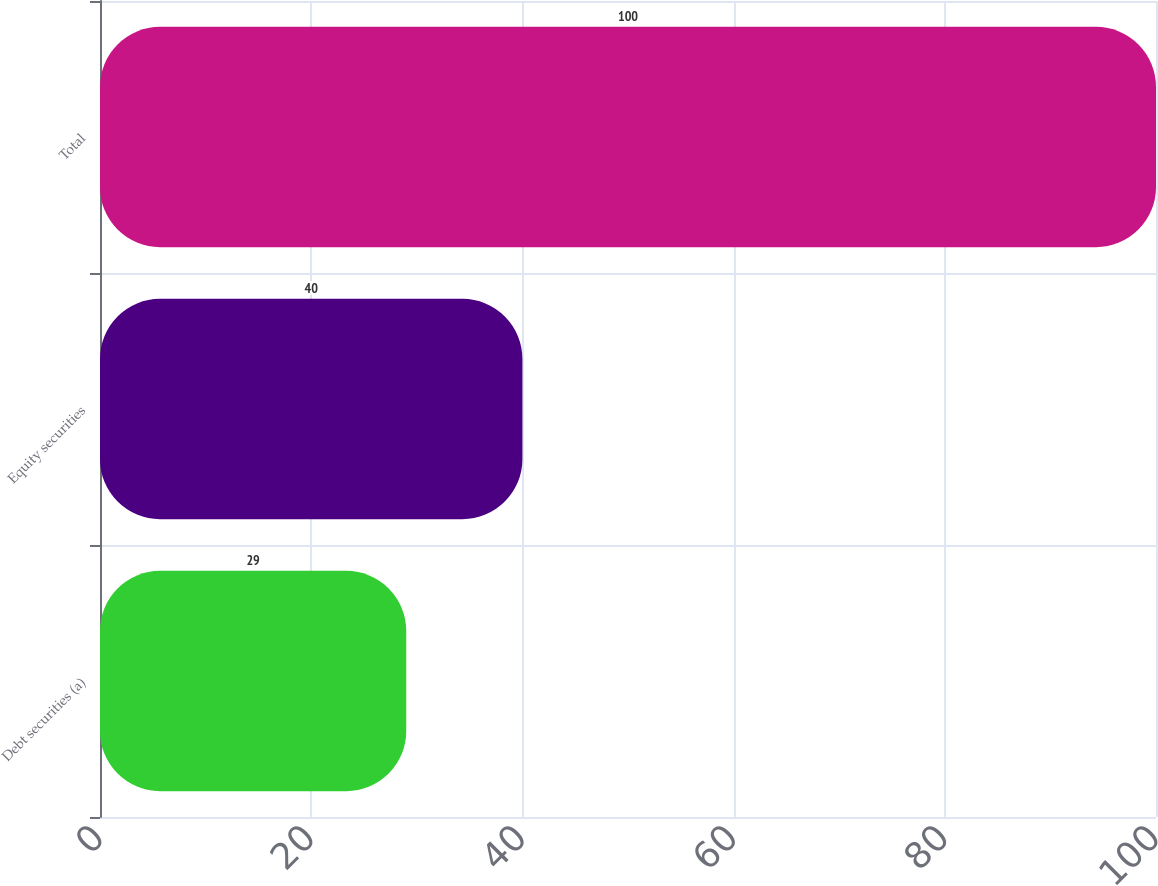<chart> <loc_0><loc_0><loc_500><loc_500><bar_chart><fcel>Debt securities (a)<fcel>Equity securities<fcel>Total<nl><fcel>29<fcel>40<fcel>100<nl></chart> 